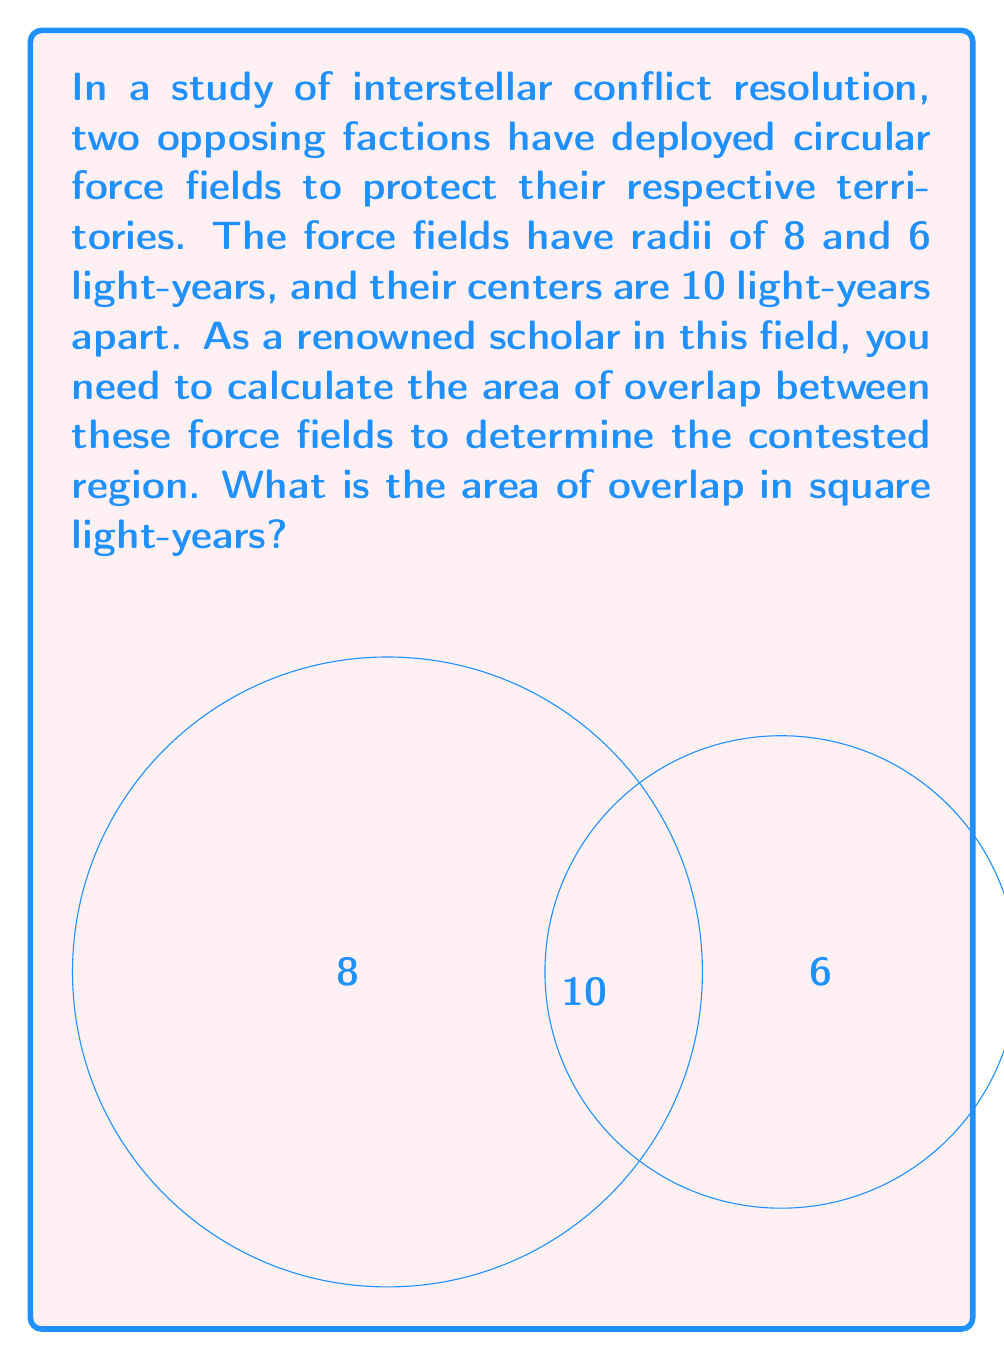Can you solve this math problem? Let's approach this step-by-step:

1) This is a problem of finding the area of intersection of two circles. We can use the formula for the area of intersection:

   $$A = r_1^2 \arccos(\frac{d^2 + r_1^2 - r_2^2}{2dr_1}) + r_2^2 \arccos(\frac{d^2 + r_2^2 - r_1^2}{2dr_2}) - \frac{1}{2}\sqrt{(-d+r_1+r_2)(d+r_1-r_2)(d-r_1+r_2)(d+r_1+r_2)}$$

   Where $r_1$ and $r_2$ are the radii of the circles, and $d$ is the distance between their centers.

2) In our case:
   $r_1 = 8$ light-years
   $r_2 = 6$ light-years
   $d = 10$ light-years

3) Let's substitute these values into the formula:

   $$A = 8^2 \arccos(\frac{10^2 + 8^2 - 6^2}{2 \cdot 10 \cdot 8}) + 6^2 \arccos(\frac{10^2 + 6^2 - 8^2}{2 \cdot 10 \cdot 6}) - \frac{1}{2}\sqrt{(-10+8+6)(10+8-6)(10-8+6)(10+8+6)}$$

4) Simplify inside the arccos functions:
   
   $$A = 64 \arccos(\frac{164}{160}) + 36 \arccos(\frac{136}{120}) - \frac{1}{2}\sqrt{4 \cdot 12 \cdot 8 \cdot 24}$$

5) Calculate the values inside arccos:
   
   $$A = 64 \arccos(1.025) + 36 \arccos(1.133) - \frac{1}{2}\sqrt{9216}$$

6) The arccos of a value greater than 1 is undefined in real numbers. This means the circles don't intersect, and there is no area of overlap.
Answer: 0 square light-years 